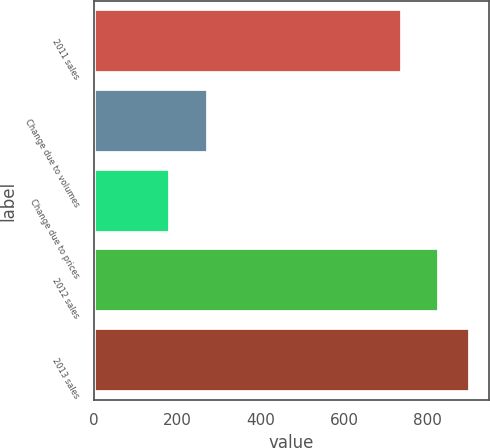Convert chart to OTSL. <chart><loc_0><loc_0><loc_500><loc_500><bar_chart><fcel>2011 sales<fcel>Change due to volumes<fcel>Change due to prices<fcel>2012 sales<fcel>2013 sales<nl><fcel>739<fcel>273<fcel>184<fcel>828<fcel>902<nl></chart> 